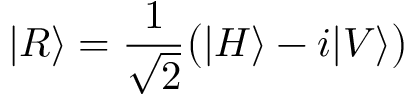Convert formula to latex. <formula><loc_0><loc_0><loc_500><loc_500>| R \rangle = { \frac { 1 } { \sqrt { 2 } } } { \left ( } | H \rangle - i | V \rangle { \right ) }</formula> 